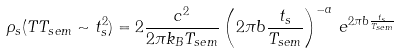<formula> <loc_0><loc_0><loc_500><loc_500>\rho _ { s } ( T T _ { s e m } \sim t _ { s } ^ { 2 } ) = 2 \frac { c ^ { 2 } } { 2 \pi k _ { B } T _ { s e m } } \left ( 2 \pi b \frac { t _ { s } } { T _ { s e m } } \right ) ^ { - a } \, e ^ { 2 \pi b \frac { t _ { s } } { T _ { s e m } } }</formula> 